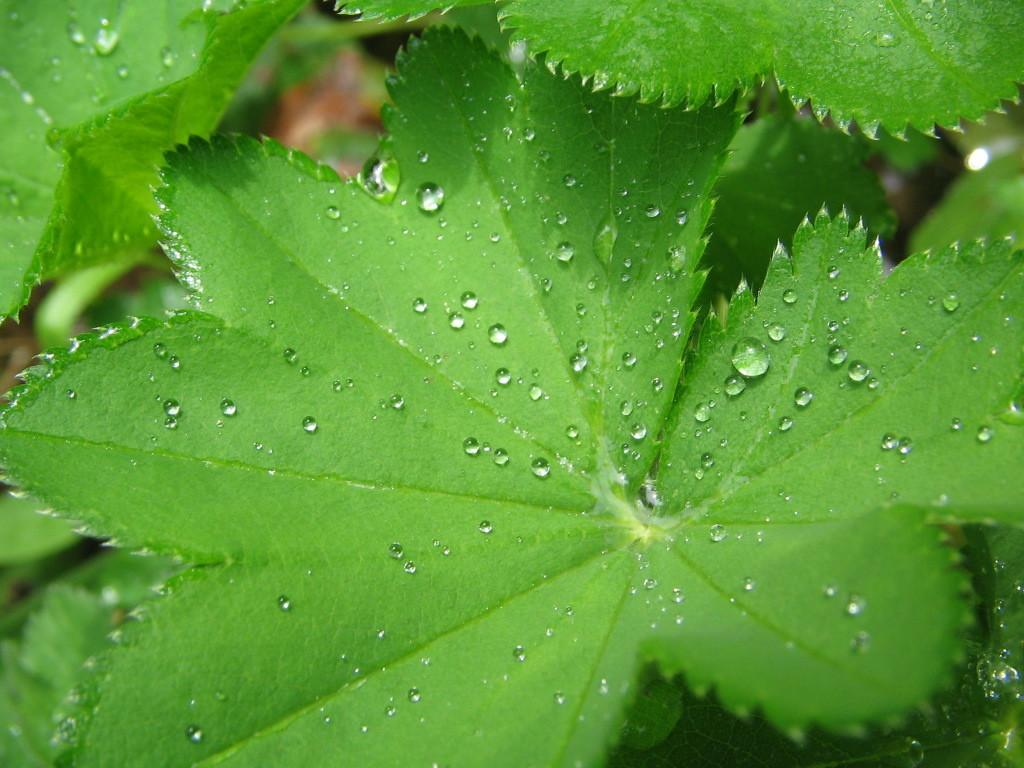What type of vegetation is present in the image? There are leaves in the image. Can you describe the condition of the leaves? There are water drops on the leaves. What is the price of the horse in the image? There is no horse present in the image, so it is not possible to determine the price. 